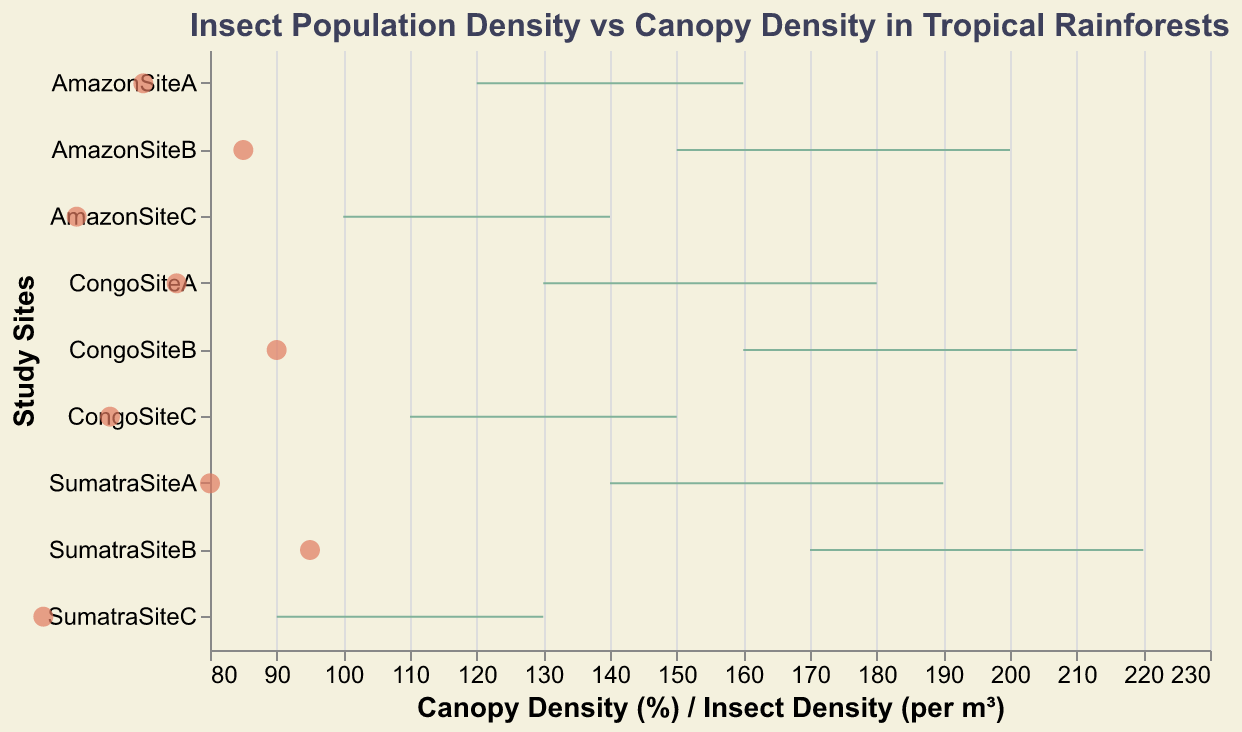What is the title of the figure? The title is typically displayed at the top of the figure. It summarizes what the figure is about.
Answer: Insect Population Density vs Canopy Density in Tropical Rainforests How many study sites are represented in the figure? To determine the number of study sites, count the unique names on the y-axis.
Answer: 9 Which site has the highest maximum insect population density? Look at the x2 position of the bars and find the one with the highest value.
Answer: SumatraSiteB What are the minimum and maximum insect population densities for AmazonSiteC? Look for the range bar corresponding to AmazonSiteC and read the minimum and maximum values from the x-axis.
Answer: Min: 100, Max: 140 Which site has the highest canopy density? Look at the point marks representing canopy density and find the point with the highest x-value.
Answer: SumatraSiteB Compare the maximum insect population densities between CongoSiteA and CongoSiteB. Which one is higher and by how much? Find the maximum insect density values for CongoSiteA and CongoSiteB, then subtract the smaller from the larger.
Answer: CongoSiteB is higher by 30 (210 - 180) What is the range of insect densities at SumatraSiteA? Identify SumatraSiteA, then find the difference between the maximum and minimum insect densities.
Answer: 190 - 140 = 50 Which site has the smallest range of insect population densities and what is the range? Calculate the range (max - min) for each site and identify the smallest.
Answer: SumatraSiteC: 130 - 90 = 40 What is the average canopy density of all study sites? Sum all the canopy density values and divide by the number of sites (9).
Answer: (70 + 85 + 60 + 75 + 90 + 65 + 80 + 95 + 55) / 9 = 75.56 Is there a positive correlation between canopy density and maximum insect population density? Observe if sites with higher canopy densities tend to have higher maximum insect population densities; you can assess this by looking at the upward trend in the data points.
Answer: Yes 